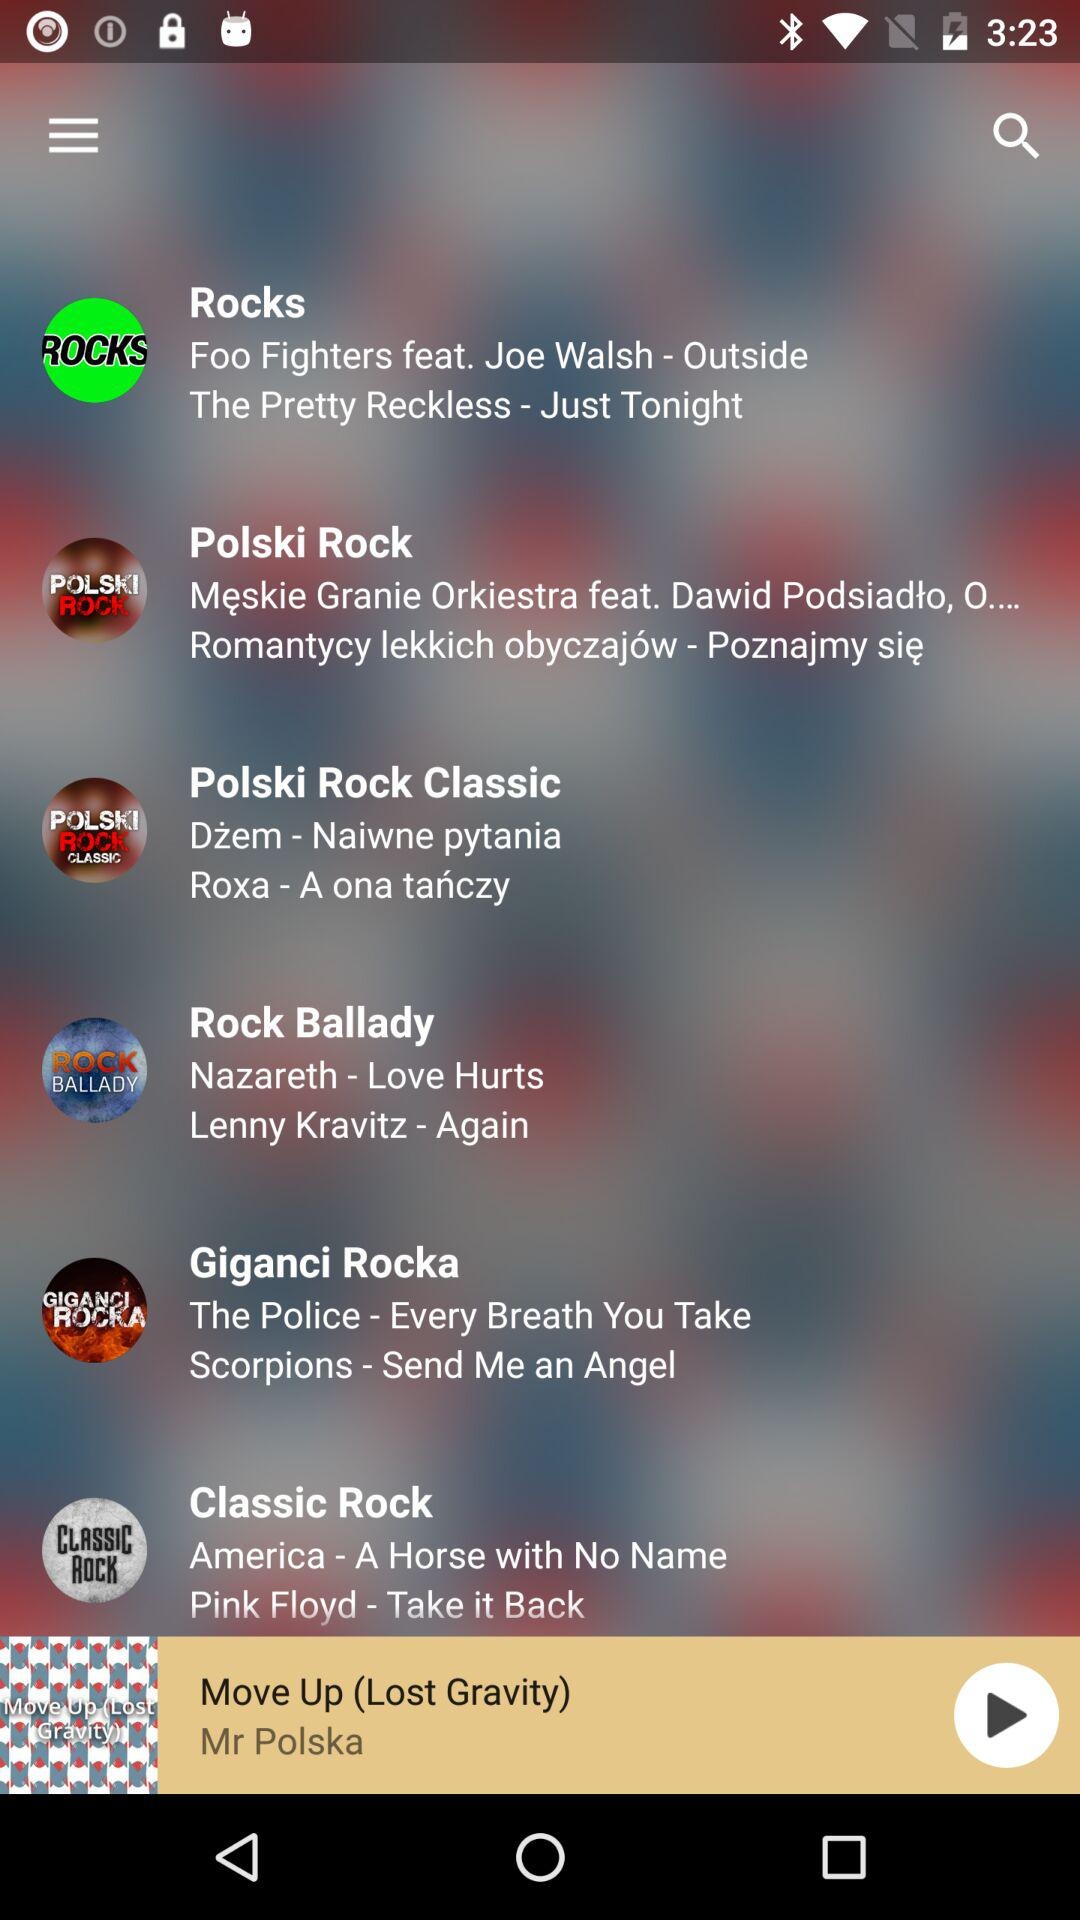Who is the singer of Move Up? The singer of Move Up is Mr. Polska. 